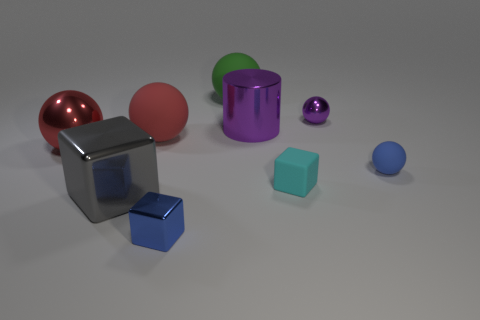Subtract all small blue matte balls. How many balls are left? 4 Subtract all gray cubes. How many cubes are left? 2 Subtract all blocks. How many objects are left? 6 Add 2 small purple metallic things. How many small purple metallic things are left? 3 Add 3 tiny brown rubber balls. How many tiny brown rubber balls exist? 3 Subtract 1 gray blocks. How many objects are left? 8 Subtract 1 cylinders. How many cylinders are left? 0 Subtract all blue balls. Subtract all red cylinders. How many balls are left? 4 Subtract all blue blocks. How many red balls are left? 2 Subtract all purple matte things. Subtract all big metallic cubes. How many objects are left? 8 